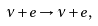<formula> <loc_0><loc_0><loc_500><loc_500>\nu + e \rightarrow \nu + e ,</formula> 